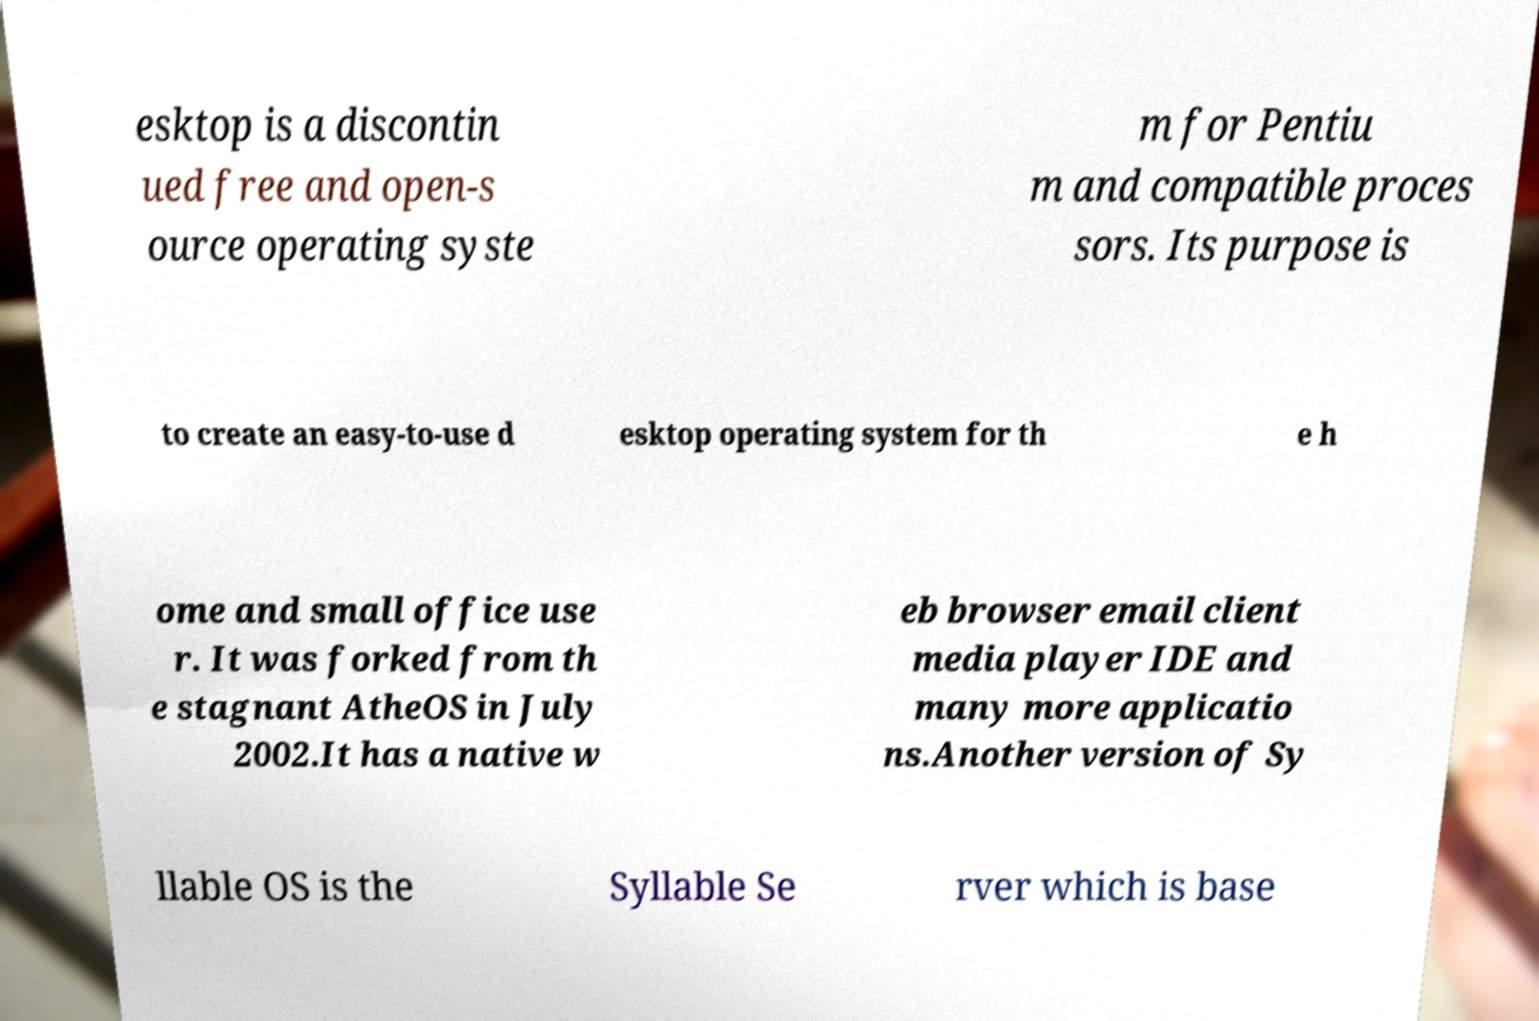Can you read and provide the text displayed in the image?This photo seems to have some interesting text. Can you extract and type it out for me? esktop is a discontin ued free and open-s ource operating syste m for Pentiu m and compatible proces sors. Its purpose is to create an easy-to-use d esktop operating system for th e h ome and small office use r. It was forked from th e stagnant AtheOS in July 2002.It has a native w eb browser email client media player IDE and many more applicatio ns.Another version of Sy llable OS is the Syllable Se rver which is base 